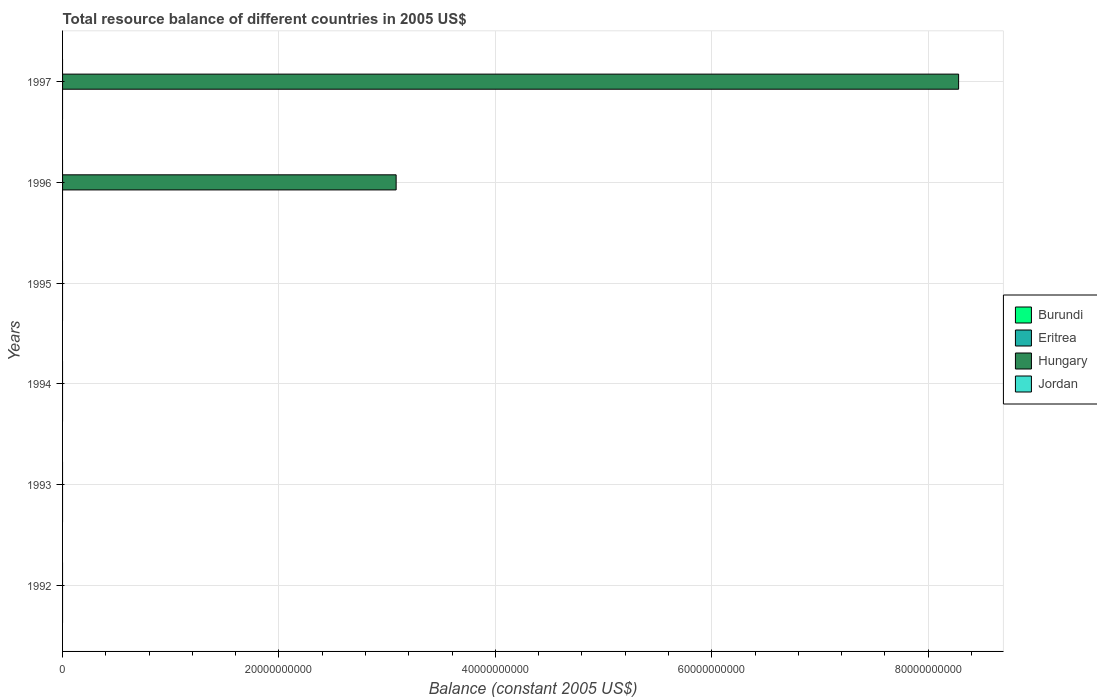How many different coloured bars are there?
Your response must be concise. 1. Are the number of bars per tick equal to the number of legend labels?
Give a very brief answer. No. How many bars are there on the 6th tick from the bottom?
Your response must be concise. 1. What is the label of the 6th group of bars from the top?
Offer a very short reply. 1992. In how many cases, is the number of bars for a given year not equal to the number of legend labels?
Offer a very short reply. 6. Across all years, what is the maximum total resource balance in Hungary?
Ensure brevity in your answer.  8.28e+1. What is the total total resource balance in Burundi in the graph?
Make the answer very short. 0. What is the average total resource balance in Hungary per year?
Give a very brief answer. 1.89e+1. In how many years, is the total resource balance in Hungary greater than 44000000000 US$?
Your response must be concise. 1. In how many years, is the total resource balance in Eritrea greater than the average total resource balance in Eritrea taken over all years?
Ensure brevity in your answer.  0. Is it the case that in every year, the sum of the total resource balance in Hungary and total resource balance in Burundi is greater than the total resource balance in Eritrea?
Make the answer very short. No. How many bars are there?
Provide a succinct answer. 2. How many years are there in the graph?
Make the answer very short. 6. What is the difference between two consecutive major ticks on the X-axis?
Ensure brevity in your answer.  2.00e+1. Does the graph contain any zero values?
Make the answer very short. Yes. How many legend labels are there?
Your answer should be very brief. 4. What is the title of the graph?
Your answer should be compact. Total resource balance of different countries in 2005 US$. What is the label or title of the X-axis?
Your answer should be very brief. Balance (constant 2005 US$). What is the Balance (constant 2005 US$) of Burundi in 1992?
Keep it short and to the point. 0. What is the Balance (constant 2005 US$) in Eritrea in 1992?
Offer a terse response. 0. What is the Balance (constant 2005 US$) in Hungary in 1992?
Offer a terse response. 0. What is the Balance (constant 2005 US$) in Burundi in 1993?
Keep it short and to the point. 0. What is the Balance (constant 2005 US$) of Hungary in 1993?
Give a very brief answer. 0. What is the Balance (constant 2005 US$) in Hungary in 1994?
Provide a succinct answer. 0. What is the Balance (constant 2005 US$) in Burundi in 1995?
Offer a terse response. 0. What is the Balance (constant 2005 US$) in Eritrea in 1995?
Provide a short and direct response. 0. What is the Balance (constant 2005 US$) of Hungary in 1996?
Offer a very short reply. 3.08e+1. What is the Balance (constant 2005 US$) of Jordan in 1996?
Your response must be concise. 0. What is the Balance (constant 2005 US$) of Hungary in 1997?
Ensure brevity in your answer.  8.28e+1. Across all years, what is the maximum Balance (constant 2005 US$) of Hungary?
Your answer should be compact. 8.28e+1. Across all years, what is the minimum Balance (constant 2005 US$) in Hungary?
Ensure brevity in your answer.  0. What is the total Balance (constant 2005 US$) of Burundi in the graph?
Provide a succinct answer. 0. What is the total Balance (constant 2005 US$) of Eritrea in the graph?
Your answer should be very brief. 0. What is the total Balance (constant 2005 US$) in Hungary in the graph?
Keep it short and to the point. 1.14e+11. What is the difference between the Balance (constant 2005 US$) of Hungary in 1996 and that in 1997?
Offer a very short reply. -5.20e+1. What is the average Balance (constant 2005 US$) in Burundi per year?
Your response must be concise. 0. What is the average Balance (constant 2005 US$) in Eritrea per year?
Offer a terse response. 0. What is the average Balance (constant 2005 US$) in Hungary per year?
Keep it short and to the point. 1.89e+1. What is the average Balance (constant 2005 US$) of Jordan per year?
Give a very brief answer. 0. What is the ratio of the Balance (constant 2005 US$) of Hungary in 1996 to that in 1997?
Offer a terse response. 0.37. What is the difference between the highest and the lowest Balance (constant 2005 US$) in Hungary?
Give a very brief answer. 8.28e+1. 